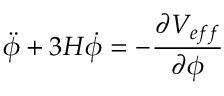<formula> <loc_0><loc_0><loc_500><loc_500>\ddot { \phi } + 3 H \dot { \phi } = - \frac { { \partial } V _ { e f f } } { { \partial } { \phi } }</formula> 